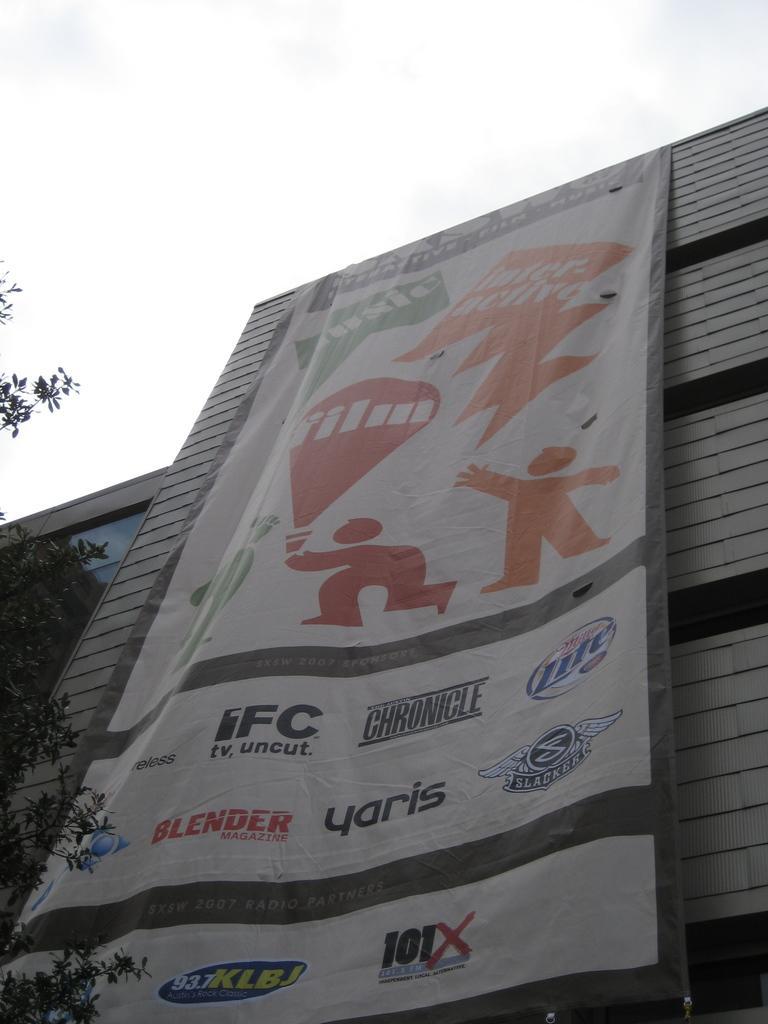How would you summarize this image in a sentence or two? There is a poster on a building and a tree in the foreground area of the image, there is the sky in the background. 